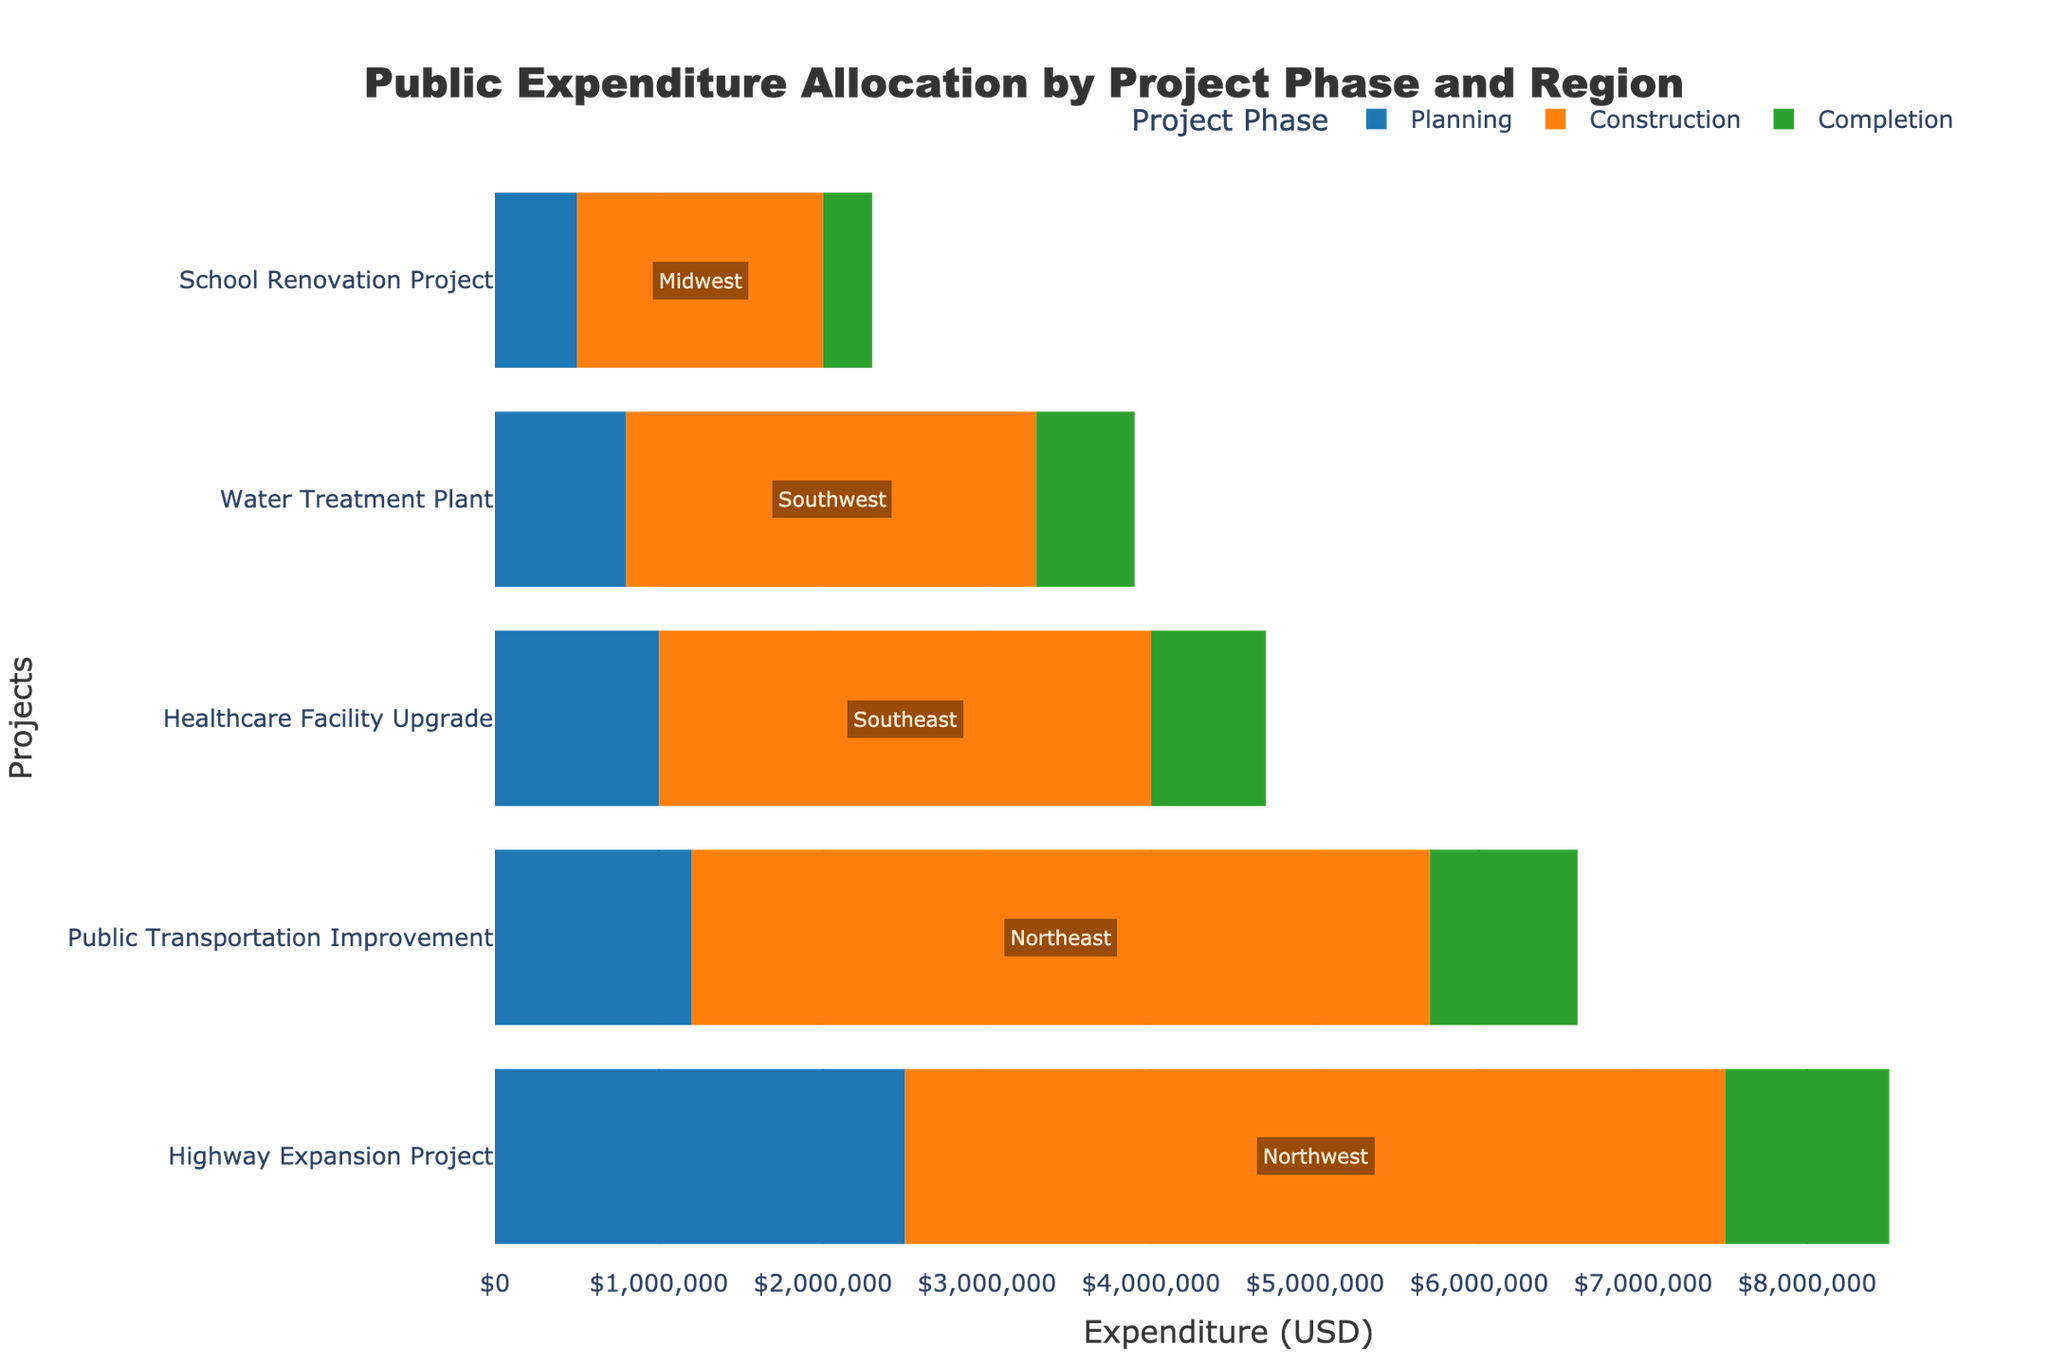Which project has the highest total expenditure? To find the project with the highest total expenditure, sum up the expenditures for each phase (Planning, Construction, Completion) per project and compare them. The project with the highest combined expenditure is "Public Transportation Improvement".
Answer: Public Transportation Improvement What is the total expenditure for the "Healthcare Facility Upgrade" project? Add the expenditures for each phase of the "Healthcare Facility Upgrade": Planning ($1,000,000) + Construction ($3,000,000) + Completion ($700,000). This gives $4,700,000.
Answer: $4,700,000 Which region has the project with the lowest total expenditure? Find the project with the lowest total expenditure by adding expenditures across all phases and then identify its region. The project with the lowest total expenditure is "School Renovation Project" located in the Midwest.
Answer: Midwest How does the expenditure for the Planning phase compare between the "Water Treatment Plant" and the "Public Transportation Improvement"? Check the Planning phase expenditures for both projects: "Water Treatment Plant" ($800,000) and "Public Transportation Improvement" ($1,200,000). The "Public Transportation Improvement" has a higher Planning phase expenditure.
Answer: Public Transportation Improvement Which project phase has the highest expenditure for the "Highway Expansion Project"? Compare the expenditures for the Planning ($2,500,000), Construction ($5,000,000), and Completion ($1,000,000) phases of "Highway Expansion Project". The Construction phase has the highest expenditure.
Answer: Construction What is the total expenditure across all regions for the Completion phase? Sum the expenditures for Completion phase across all projects: $1,000,000 (Highway Expansion) + $300,000 (School Renovation) + $700,000 (Healthcare Facility) + $600,000 (Water Treatment) + $900,000 (Public Transportation) totaling to $3,500,000.
Answer: $3,500,000 Which phase has the most expenditure in the "Northeast" region? For the "Public Transportation Improvement" project in the Northeast: Planning ($1,200,000), Construction ($4,500,000), Completion ($900,000). The Construction phase has the most expenditure.
Answer: Construction What is the difference in total expenditure between the "School Renovation Project" and the "Water Treatment Plant"? Calculate the total expenditures: School Renovation ($2,300,000), Water Treatment ($3,900,000). The difference is $3,900,000 - $2,300,000 = $1,600,000.
Answer: $1,600,000 Which project has the smallest proportion of its total expenditure allocated to the Completion phase? Calculate the proportion of Completion expenditure for each project by dividing the Completion expenditure by the total expenditure for each project, then compare them. The "School Renovation Project" has the smallest proportion.
Answer: School Renovation Project 